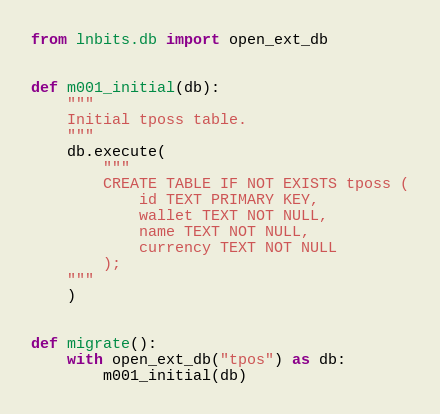Convert code to text. <code><loc_0><loc_0><loc_500><loc_500><_Python_>from lnbits.db import open_ext_db


def m001_initial(db):
    """
    Initial tposs table.
    """
    db.execute(
        """
        CREATE TABLE IF NOT EXISTS tposs (
            id TEXT PRIMARY KEY,
            wallet TEXT NOT NULL,
            name TEXT NOT NULL,
            currency TEXT NOT NULL
        );
    """
    )


def migrate():
    with open_ext_db("tpos") as db:
        m001_initial(db)
</code> 